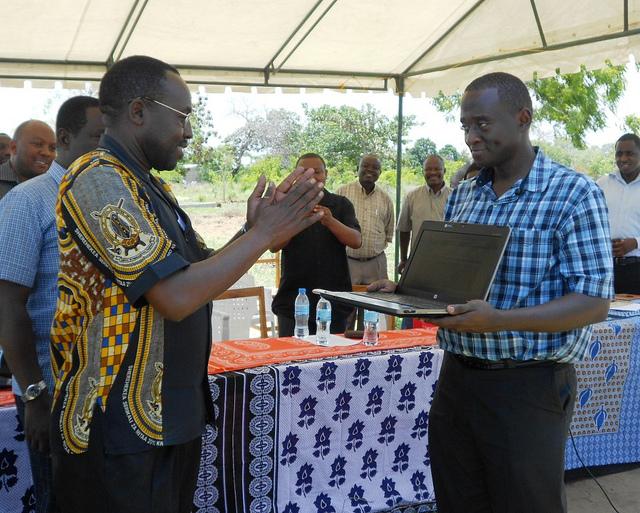How many women are in the image?
Give a very brief answer. 0. What color is the man's shirt holding the computer?
Give a very brief answer. Blue. Who is holding the computer?
Answer briefly. Man on right. 